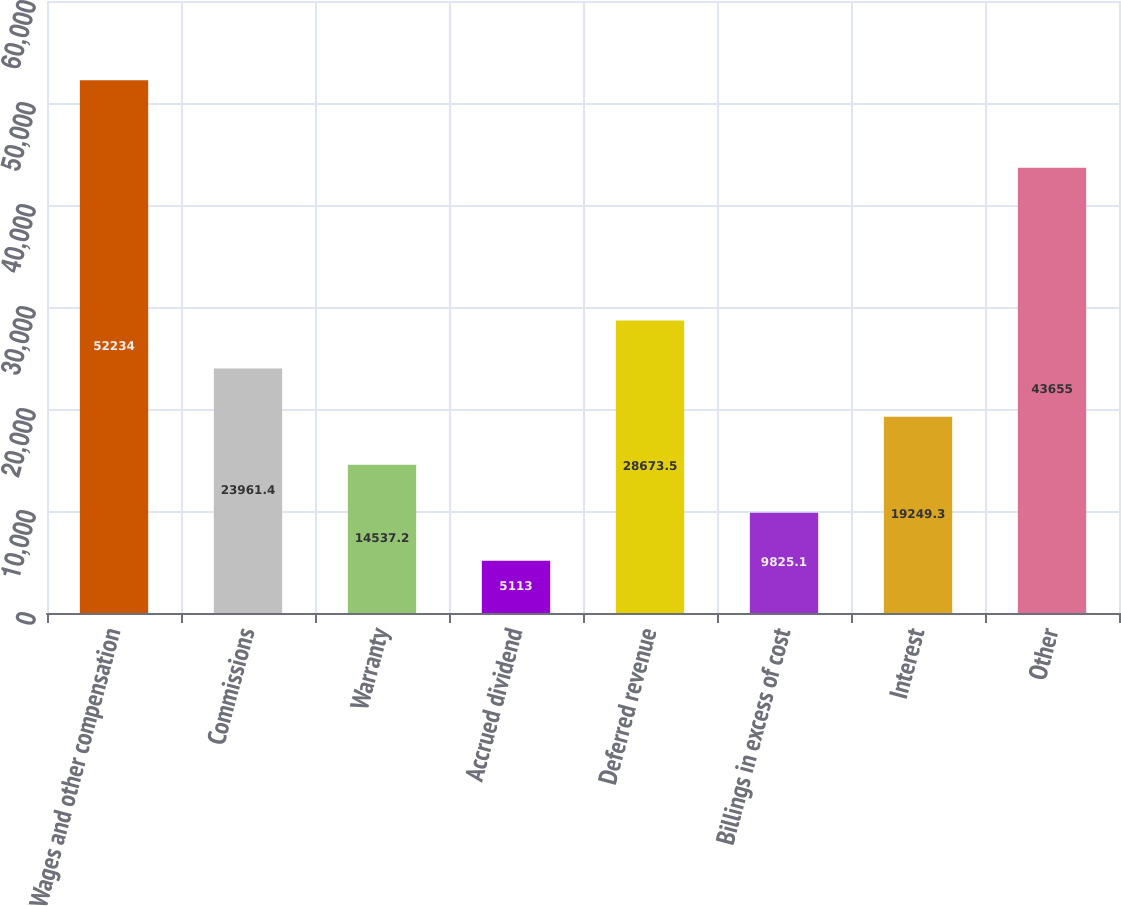Convert chart. <chart><loc_0><loc_0><loc_500><loc_500><bar_chart><fcel>Wages and other compensation<fcel>Commissions<fcel>Warranty<fcel>Accrued dividend<fcel>Deferred revenue<fcel>Billings in excess of cost<fcel>Interest<fcel>Other<nl><fcel>52234<fcel>23961.4<fcel>14537.2<fcel>5113<fcel>28673.5<fcel>9825.1<fcel>19249.3<fcel>43655<nl></chart> 